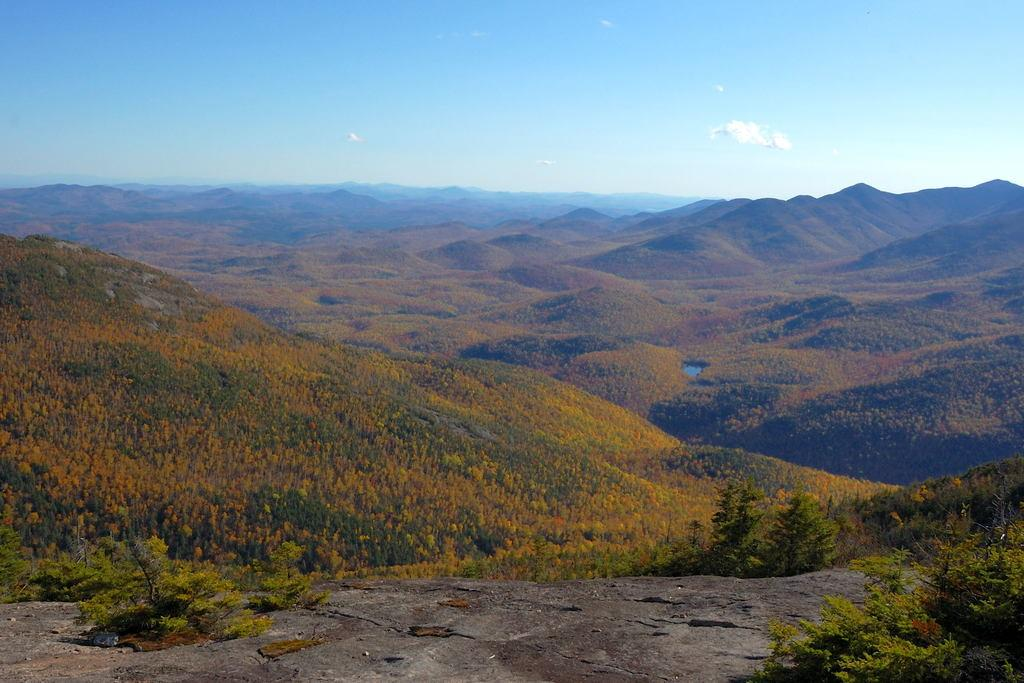What type of natural landscape is depicted in the image? The image features a group of trees, mountains, and water. Can you describe the sky in the image? The sky is visible in the background of the image. What type of print can be seen on the celery in the image? There is no celery present in the image, and therefore no print can be observed. 